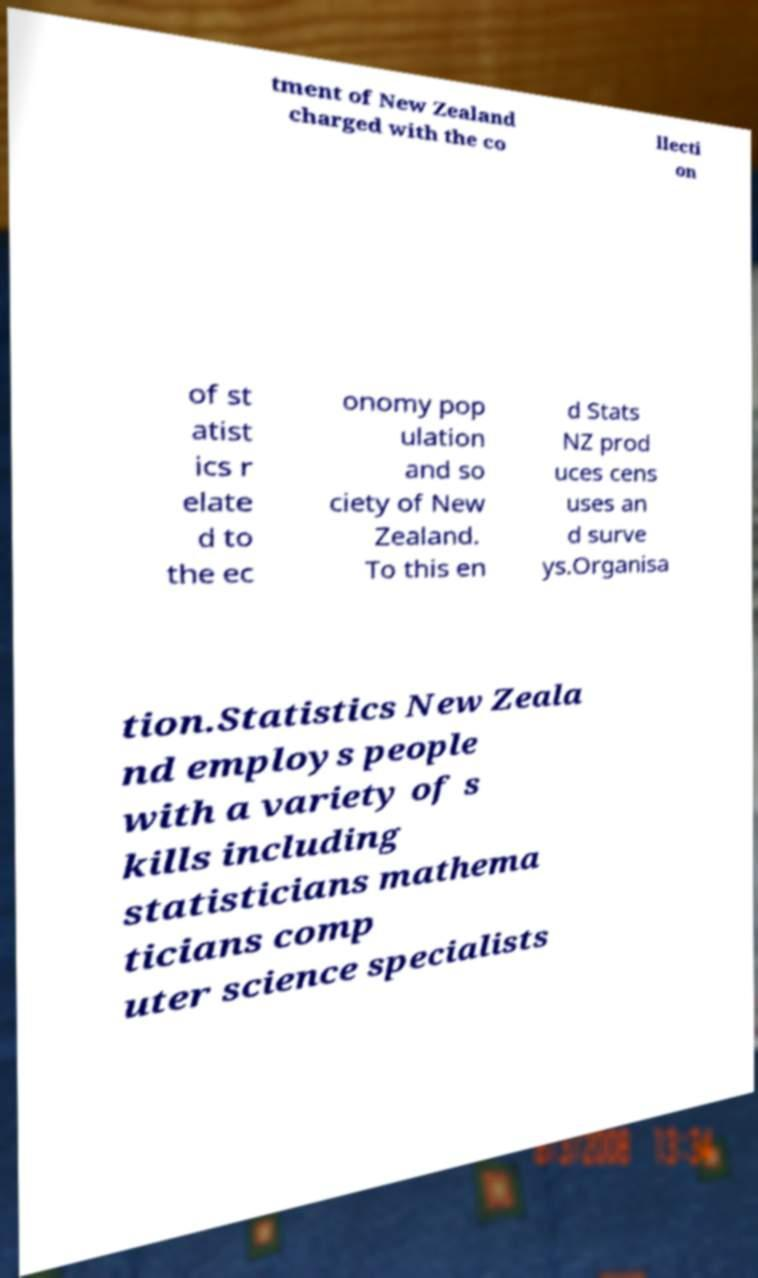I need the written content from this picture converted into text. Can you do that? tment of New Zealand charged with the co llecti on of st atist ics r elate d to the ec onomy pop ulation and so ciety of New Zealand. To this en d Stats NZ prod uces cens uses an d surve ys.Organisa tion.Statistics New Zeala nd employs people with a variety of s kills including statisticians mathema ticians comp uter science specialists 